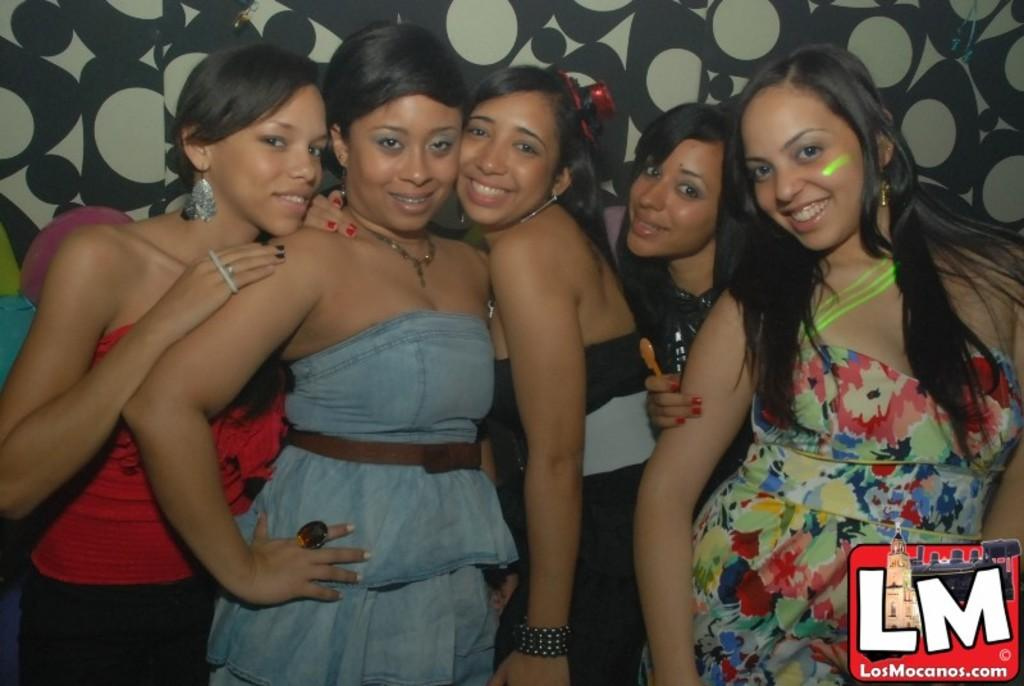Who is present in the image? There are people in the image. What are the people doing in the image? The people are standing and smiling. What can be seen in the background of the image? There is a designed wall in the background of the image. What is located at the bottom of the image? There is a logo at the bottom of the image. Why are the people crying in the image? The people are not crying in the image; they are standing and smiling. How many men are present in the image? The provided facts do not specify the gender of the people in the image, so we cannot determine the number of men. 